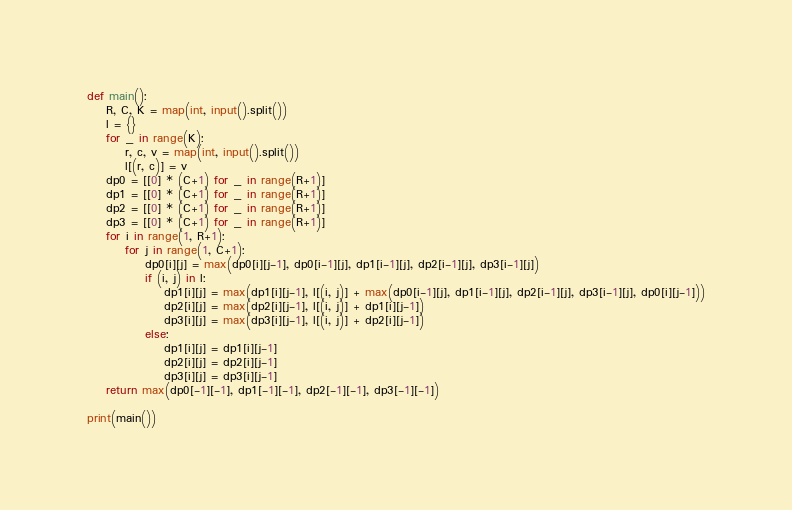Convert code to text. <code><loc_0><loc_0><loc_500><loc_500><_Python_>def main():
    R, C, K = map(int, input().split())
    l = {}
    for _ in range(K):
        r, c, v = map(int, input().split())
        l[(r, c)] = v
    dp0 = [[0] * (C+1) for _ in range(R+1)]
    dp1 = [[0] * (C+1) for _ in range(R+1)]
    dp2 = [[0] * (C+1) for _ in range(R+1)]
    dp3 = [[0] * (C+1) for _ in range(R+1)]
    for i in range(1, R+1):
        for j in range(1, C+1):
            dp0[i][j] = max(dp0[i][j-1], dp0[i-1][j], dp1[i-1][j], dp2[i-1][j], dp3[i-1][j])
            if (i, j) in l:
                dp1[i][j] = max(dp1[i][j-1], l[(i, j)] + max(dp0[i-1][j], dp1[i-1][j], dp2[i-1][j], dp3[i-1][j], dp0[i][j-1]))
                dp2[i][j] = max(dp2[i][j-1], l[(i, j)] + dp1[i][j-1])
                dp3[i][j] = max(dp3[i][j-1], l[(i, j)] + dp2[i][j-1])
            else:
                dp1[i][j] = dp1[i][j-1]
                dp2[i][j] = dp2[i][j-1]
                dp3[i][j] = dp3[i][j-1]
    return max(dp0[-1][-1], dp1[-1][-1], dp2[-1][-1], dp3[-1][-1])

print(main())
</code> 